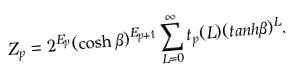Convert formula to latex. <formula><loc_0><loc_0><loc_500><loc_500>Z _ { p } = 2 ^ { E _ { p } } ( \cosh \beta ) ^ { E _ { p + 1 } } \sum _ { L = 0 } ^ { \infty } t _ { p } ( L ) ( t a n h \beta ) ^ { L } ,</formula> 